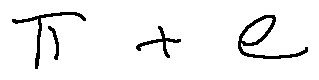<formula> <loc_0><loc_0><loc_500><loc_500>\pi + e</formula> 